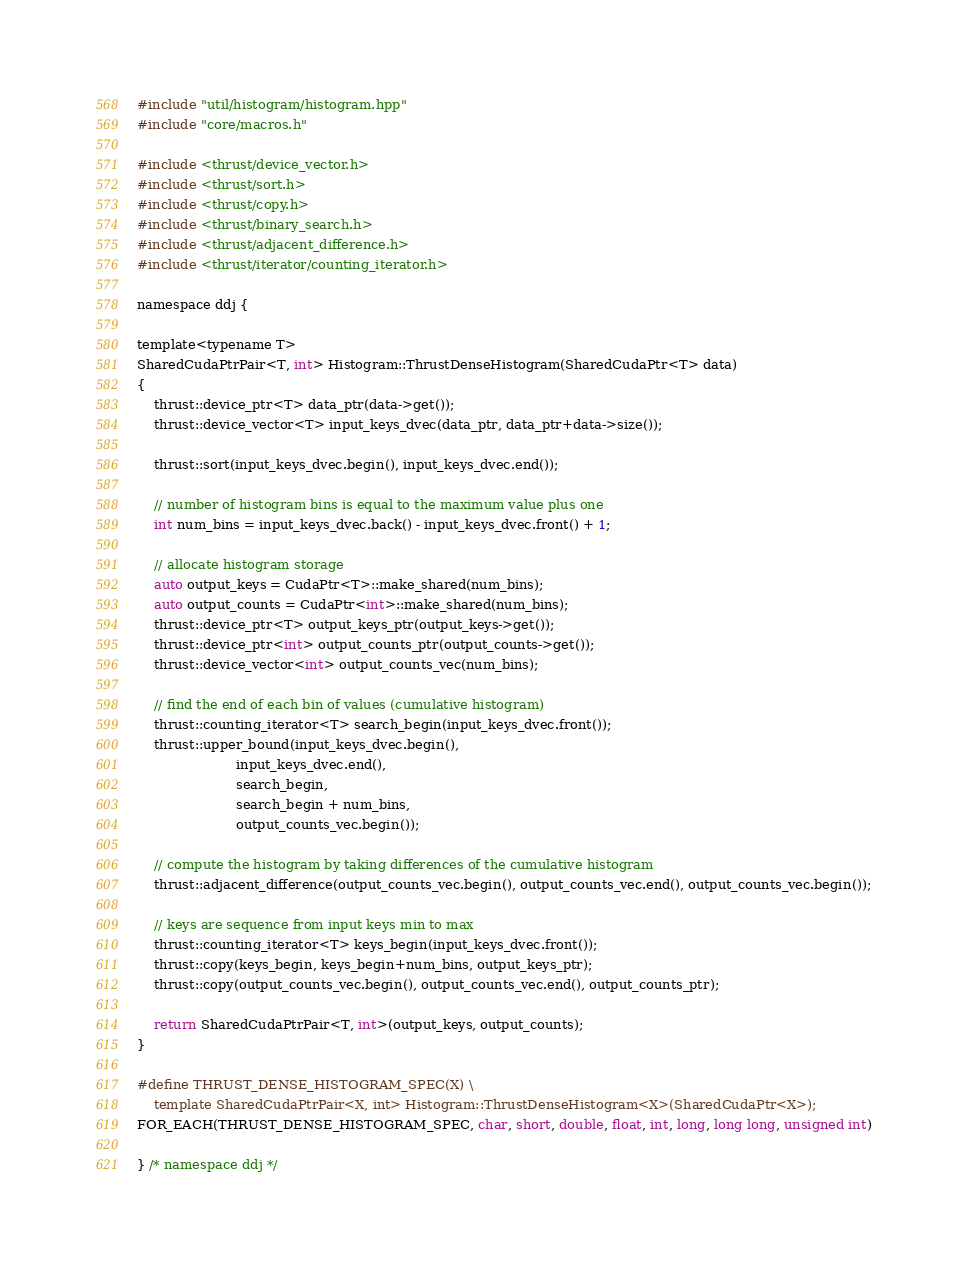Convert code to text. <code><loc_0><loc_0><loc_500><loc_500><_Cuda_>#include "util/histogram/histogram.hpp"
#include "core/macros.h"

#include <thrust/device_vector.h>
#include <thrust/sort.h>
#include <thrust/copy.h>
#include <thrust/binary_search.h>
#include <thrust/adjacent_difference.h>
#include <thrust/iterator/counting_iterator.h>

namespace ddj {

template<typename T>
SharedCudaPtrPair<T, int> Histogram::ThrustDenseHistogram(SharedCudaPtr<T> data)
{
    thrust::device_ptr<T> data_ptr(data->get());
    thrust::device_vector<T> input_keys_dvec(data_ptr, data_ptr+data->size());

    thrust::sort(input_keys_dvec.begin(), input_keys_dvec.end());

    // number of histogram bins is equal to the maximum value plus one
    int num_bins = input_keys_dvec.back() - input_keys_dvec.front() + 1;

    // allocate histogram storage
    auto output_keys = CudaPtr<T>::make_shared(num_bins);
    auto output_counts = CudaPtr<int>::make_shared(num_bins);
    thrust::device_ptr<T> output_keys_ptr(output_keys->get());
    thrust::device_ptr<int> output_counts_ptr(output_counts->get());
    thrust::device_vector<int> output_counts_vec(num_bins);

    // find the end of each bin of values (cumulative histogram)
    thrust::counting_iterator<T> search_begin(input_keys_dvec.front());
    thrust::upper_bound(input_keys_dvec.begin(),
    					input_keys_dvec.end(),
						search_begin,
						search_begin + num_bins,
						output_counts_vec.begin());

    // compute the histogram by taking differences of the cumulative histogram
    thrust::adjacent_difference(output_counts_vec.begin(), output_counts_vec.end(), output_counts_vec.begin());

    // keys are sequence from input keys min to max
    thrust::counting_iterator<T> keys_begin(input_keys_dvec.front());
    thrust::copy(keys_begin, keys_begin+num_bins, output_keys_ptr);
    thrust::copy(output_counts_vec.begin(), output_counts_vec.end(), output_counts_ptr);

    return SharedCudaPtrPair<T, int>(output_keys, output_counts);
}

#define THRUST_DENSE_HISTOGRAM_SPEC(X) \
	template SharedCudaPtrPair<X, int> Histogram::ThrustDenseHistogram<X>(SharedCudaPtr<X>);
FOR_EACH(THRUST_DENSE_HISTOGRAM_SPEC, char, short, double, float, int, long, long long, unsigned int)

} /* namespace ddj */
</code> 